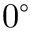Convert formula to latex. <formula><loc_0><loc_0><loc_500><loc_500>0 ^ { \circ }</formula> 